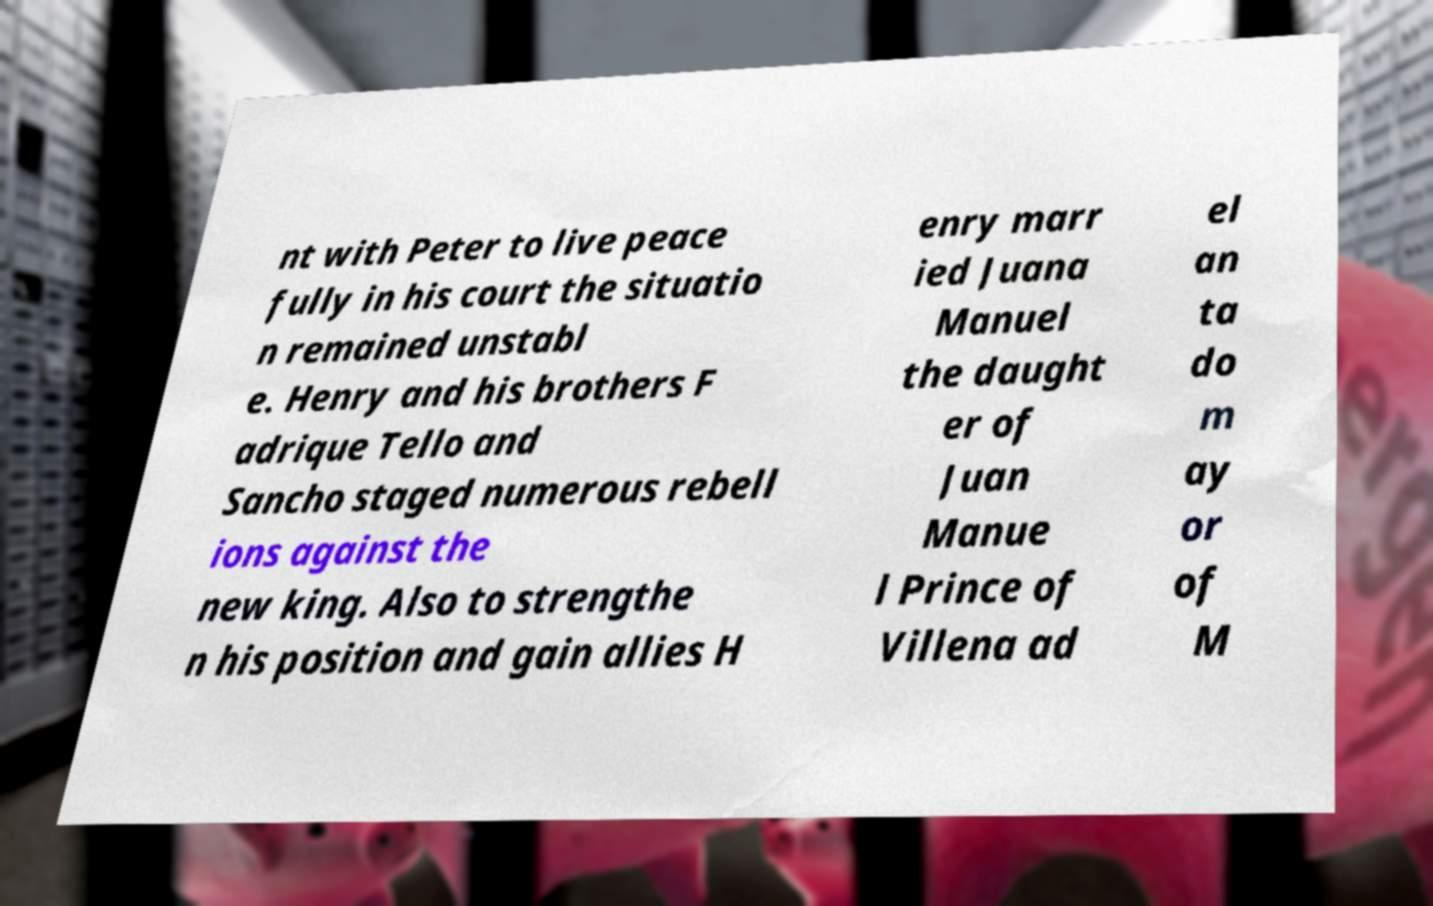Could you assist in decoding the text presented in this image and type it out clearly? nt with Peter to live peace fully in his court the situatio n remained unstabl e. Henry and his brothers F adrique Tello and Sancho staged numerous rebell ions against the new king. Also to strengthe n his position and gain allies H enry marr ied Juana Manuel the daught er of Juan Manue l Prince of Villena ad el an ta do m ay or of M 